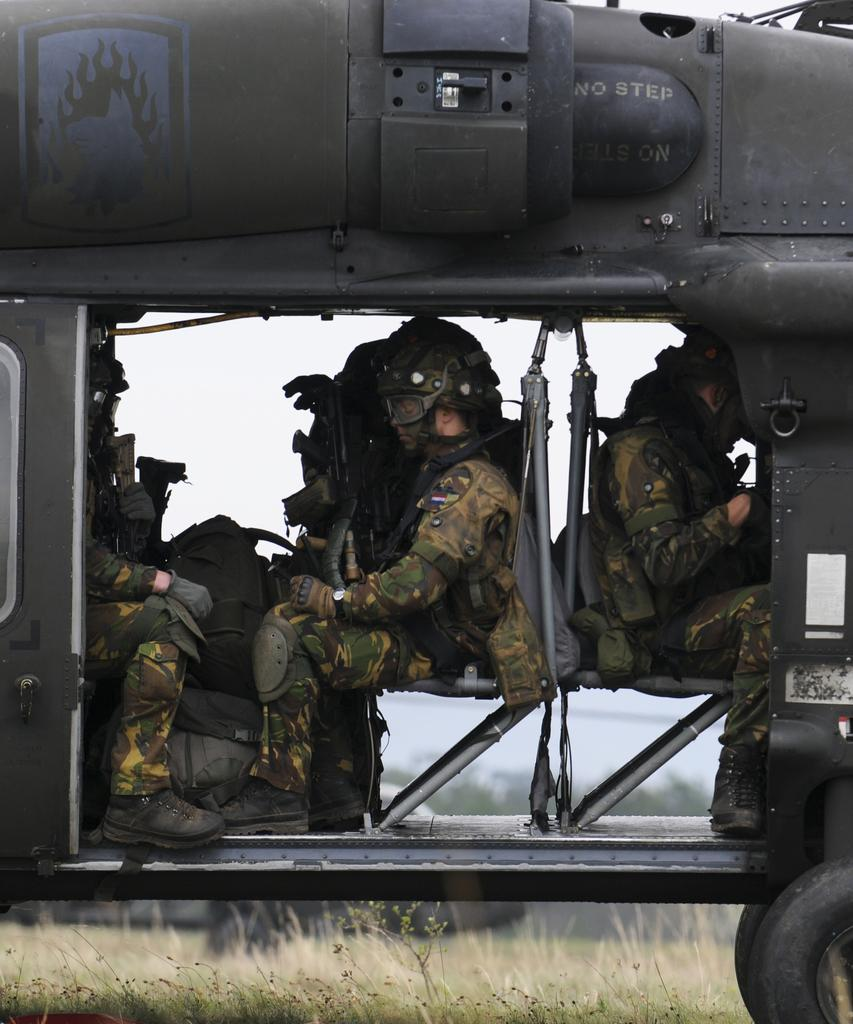What are the people in the image doing? There are persons sitting in the helicopter. What can be seen at the bottom of the image? There is grass visible at the bottom of the image. What is visible in the background of the image? There are trees and the sky visible in the background of the image. What color is the pig in the image? There is no pig present in the image. What type of silver object can be seen in the image? There is no silver object present in the image. 